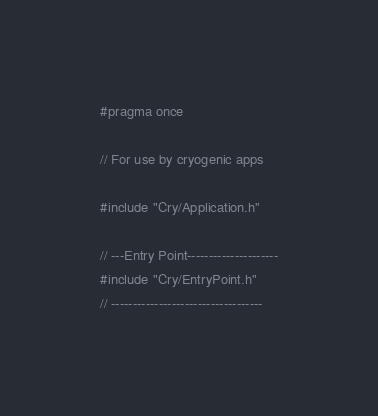Convert code to text. <code><loc_0><loc_0><loc_500><loc_500><_C_>#pragma once

// For use by cryogenic apps 

#include "Cry/Application.h"

// ---Entry Point---------------------
#include "Cry/EntryPoint.h"
// -----------------------------------</code> 